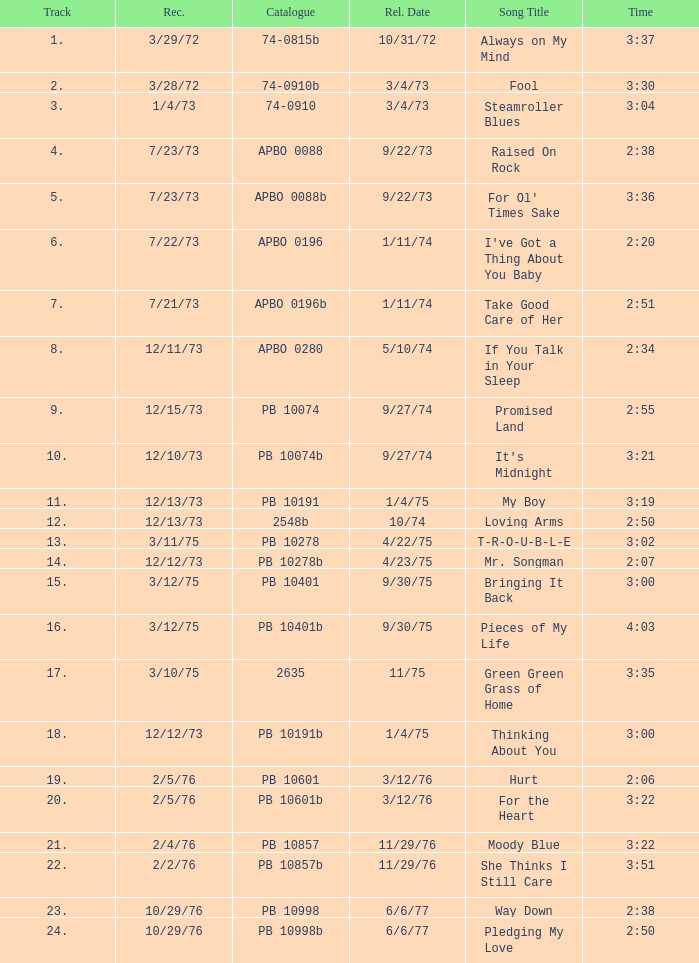Name the catalogue that has tracks less than 13 and the release date of 10/31/72 74-0815b. 